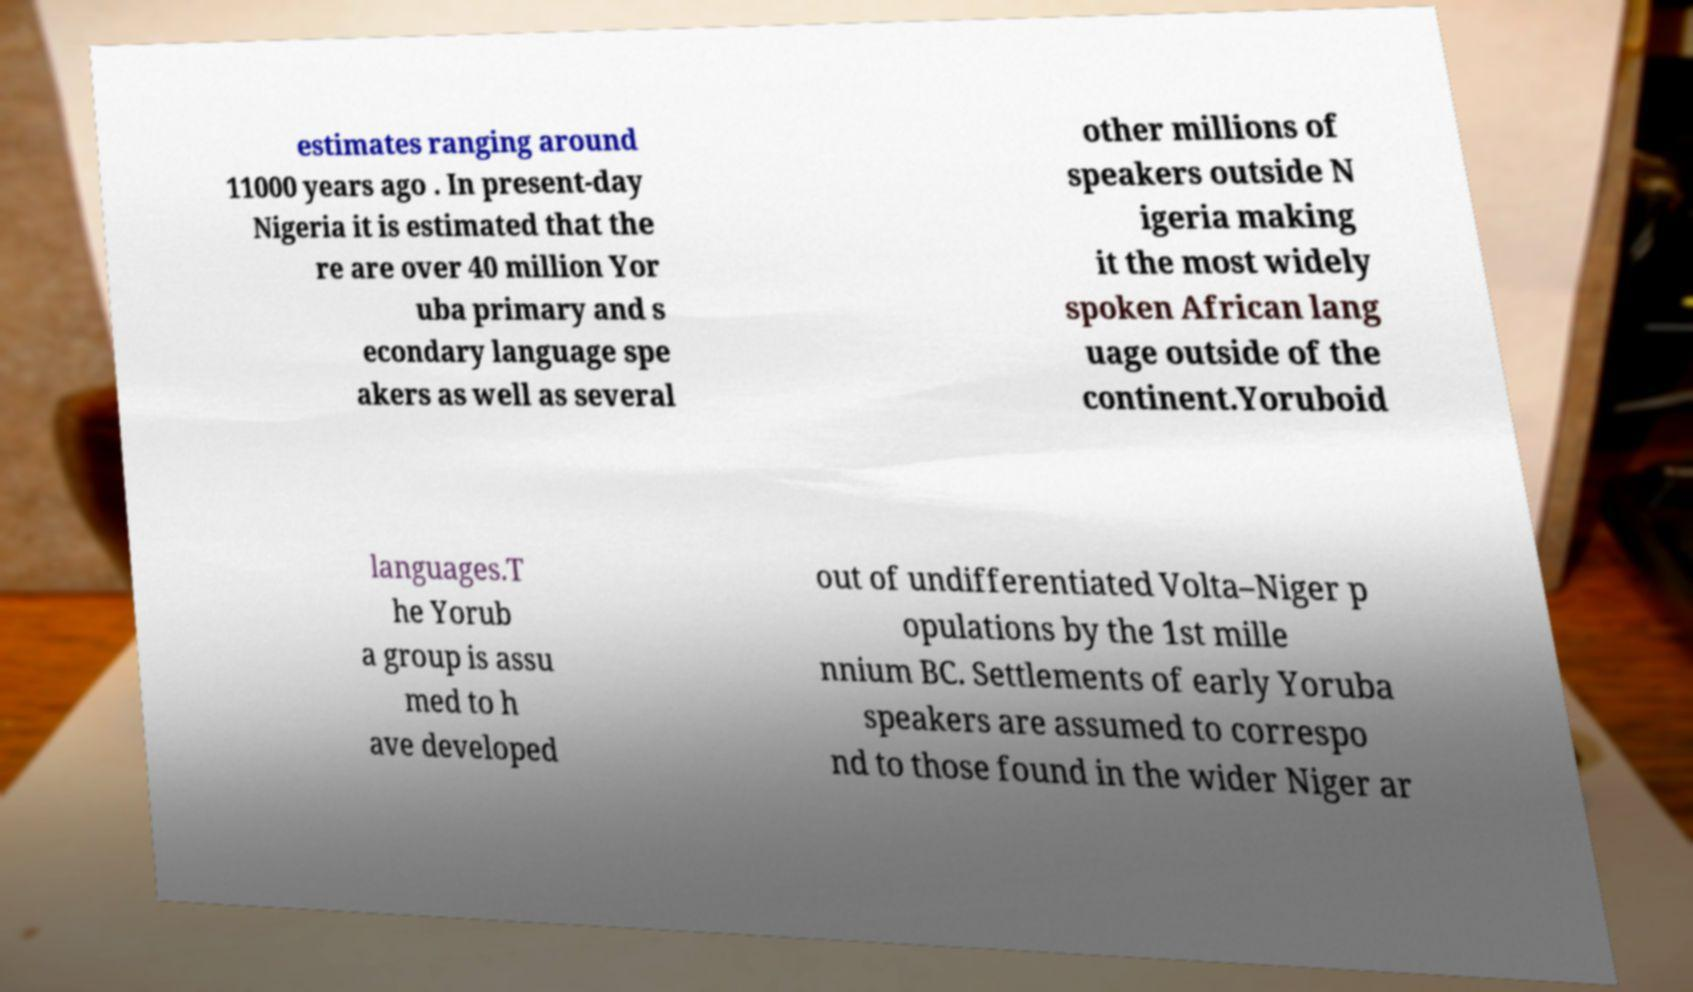For documentation purposes, I need the text within this image transcribed. Could you provide that? estimates ranging around 11000 years ago . In present-day Nigeria it is estimated that the re are over 40 million Yor uba primary and s econdary language spe akers as well as several other millions of speakers outside N igeria making it the most widely spoken African lang uage outside of the continent.Yoruboid languages.T he Yorub a group is assu med to h ave developed out of undifferentiated Volta–Niger p opulations by the 1st mille nnium BC. Settlements of early Yoruba speakers are assumed to correspo nd to those found in the wider Niger ar 